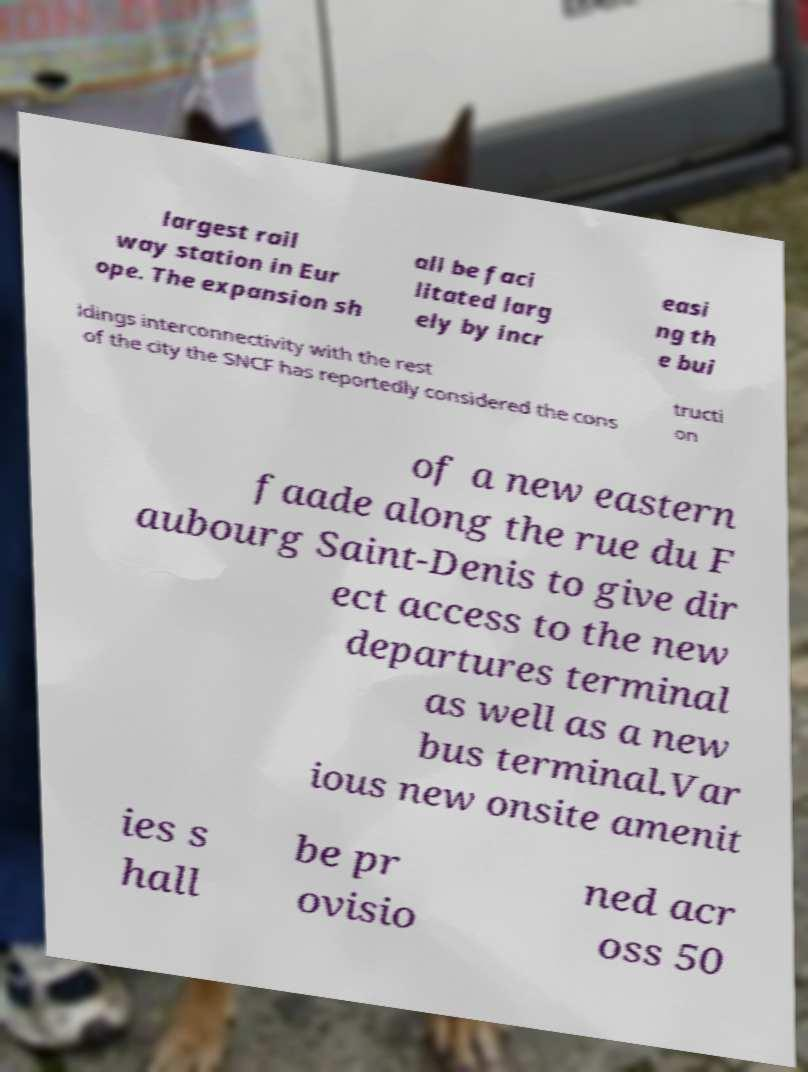What messages or text are displayed in this image? I need them in a readable, typed format. largest rail way station in Eur ope. The expansion sh all be faci litated larg ely by incr easi ng th e bui ldings interconnectivity with the rest of the city the SNCF has reportedly considered the cons tructi on of a new eastern faade along the rue du F aubourg Saint-Denis to give dir ect access to the new departures terminal as well as a new bus terminal.Var ious new onsite amenit ies s hall be pr ovisio ned acr oss 50 